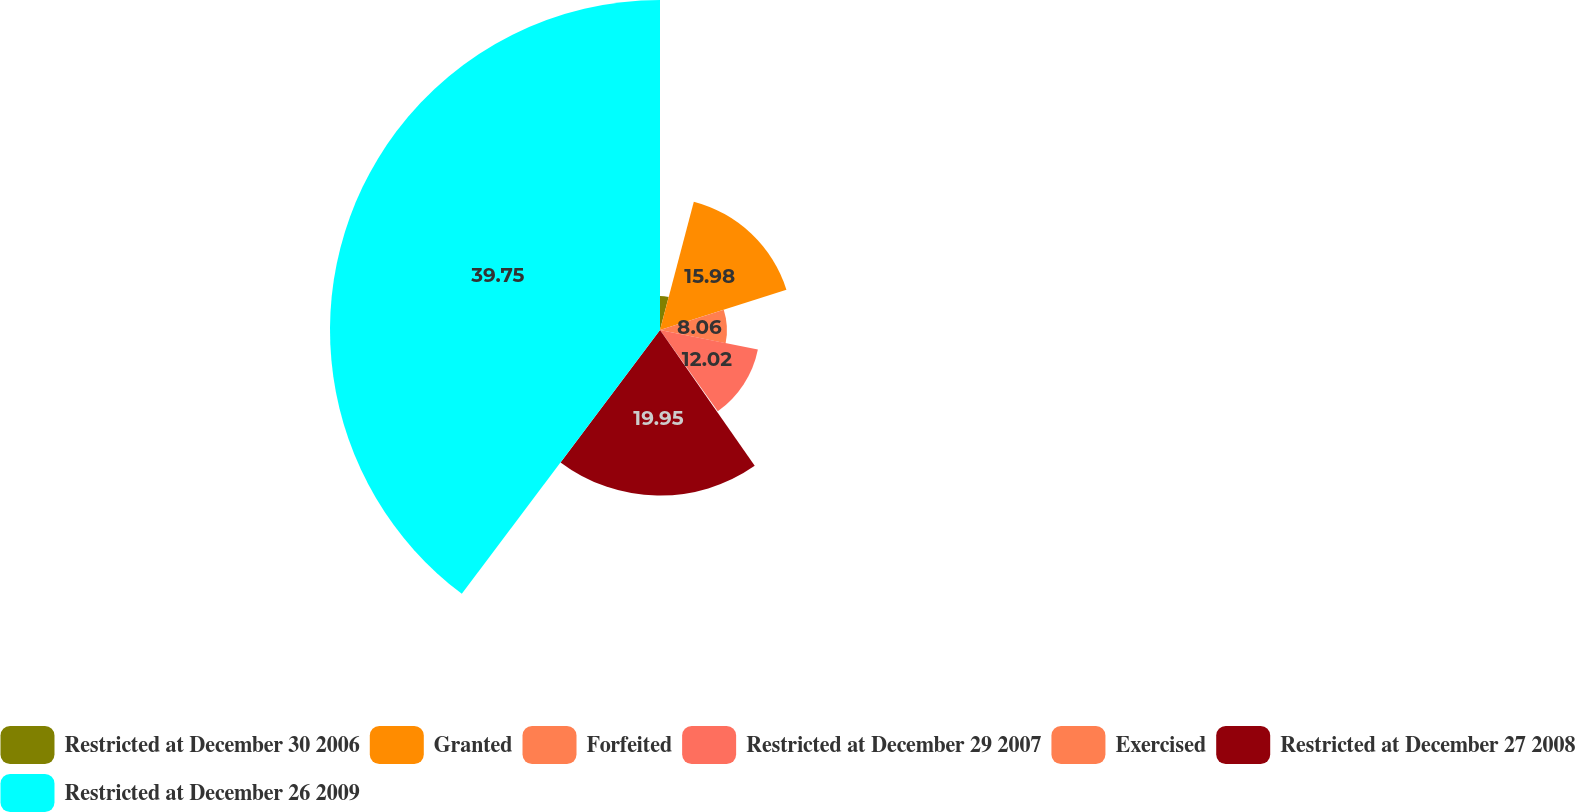Convert chart to OTSL. <chart><loc_0><loc_0><loc_500><loc_500><pie_chart><fcel>Restricted at December 30 2006<fcel>Granted<fcel>Forfeited<fcel>Restricted at December 29 2007<fcel>Exercised<fcel>Restricted at December 27 2008<fcel>Restricted at December 26 2009<nl><fcel>4.1%<fcel>15.98%<fcel>8.06%<fcel>12.02%<fcel>0.14%<fcel>19.94%<fcel>39.74%<nl></chart> 